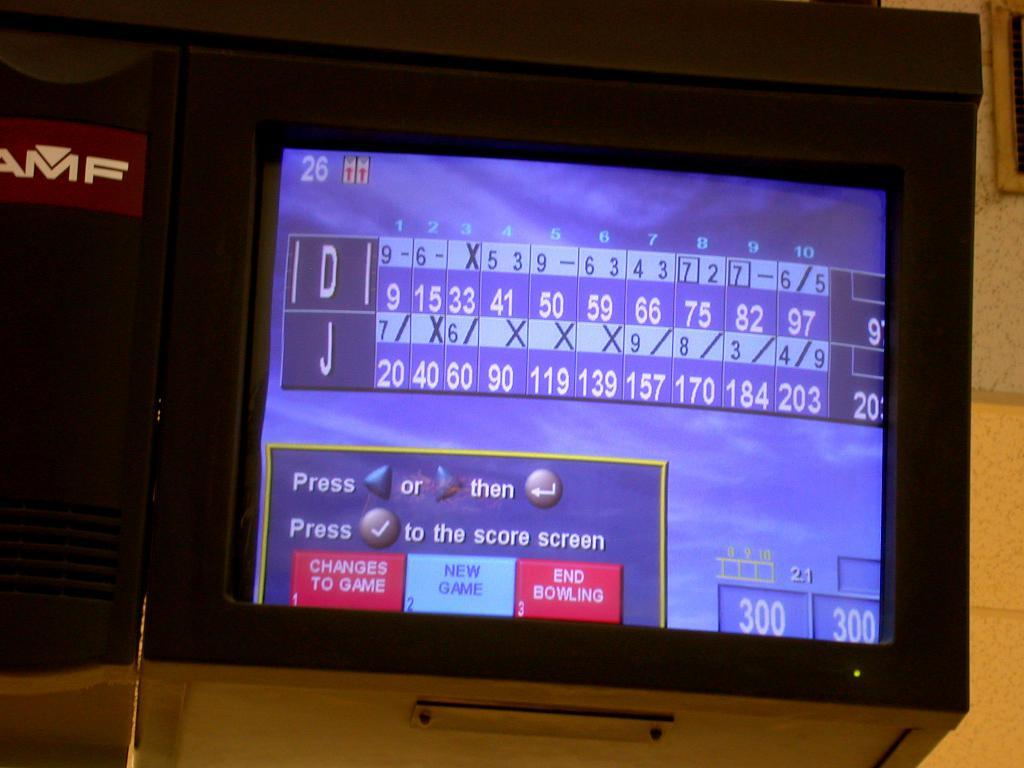<image>
Summarize the visual content of the image. The score of a bowling game has options, such as "changes to game" and "new game." 